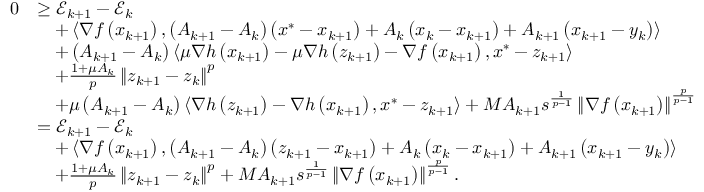<formula> <loc_0><loc_0><loc_500><loc_500>\begin{array} { r l } { 0 } & { \geq \mathcal { E } _ { k + 1 } - \mathcal { E } _ { k } } \\ & { \quad + \left \langle \nabla f \left ( x _ { k + 1 } \right ) , \left ( A _ { k + 1 } - A _ { k } \right ) \left ( x ^ { * } - x _ { k + 1 } \right ) + A _ { k } \left ( x _ { k } - x _ { k + 1 } \right ) + A _ { k + 1 } \left ( x _ { k + 1 } - y _ { k } \right ) \right \rangle } \\ & { \quad + \left ( A _ { k + 1 } - A _ { k } \right ) \left \langle \mu \nabla h \left ( x _ { k + 1 } \right ) - \mu \nabla h \left ( z _ { k + 1 } \right ) - \nabla f \left ( x _ { k + 1 } \right ) , x ^ { * } - z _ { k + 1 } \right \rangle } \\ & { \quad + \frac { 1 + \mu A _ { k } } { p } \left \| z _ { k + 1 } - z _ { k } \right \| ^ { p } } \\ & { \quad + \mu \left ( A _ { k + 1 } - A _ { k } \right ) \left \langle \nabla h \left ( z _ { k + 1 } \right ) - \nabla h \left ( x _ { k + 1 } \right ) , x ^ { * } - z _ { k + 1 } \right \rangle + M A _ { k + 1 } s ^ { \frac { 1 } { p - 1 } } \left \| \nabla f \left ( x _ { k + 1 } \right ) \right \| ^ { \frac { p } { p - 1 } } } \\ & { = \mathcal { E } _ { k + 1 } - \mathcal { E } _ { k } } \\ & { \quad + \left \langle \nabla f \left ( x _ { k + 1 } \right ) , \left ( A _ { k + 1 } - A _ { k } \right ) \left ( z _ { k + 1 } - x _ { k + 1 } \right ) + A _ { k } \left ( x _ { k } - x _ { k + 1 } \right ) + A _ { k + 1 } \left ( x _ { k + 1 } - y _ { k } \right ) \right \rangle } \\ & { \quad + \frac { 1 + \mu A _ { k } } { p } \left \| z _ { k + 1 } - z _ { k } \right \| ^ { p } + M A _ { k + 1 } s ^ { \frac { 1 } { p - 1 } } \left \| \nabla f \left ( x _ { k + 1 } \right ) \right \| ^ { \frac { p } { p - 1 } } . } \end{array}</formula> 